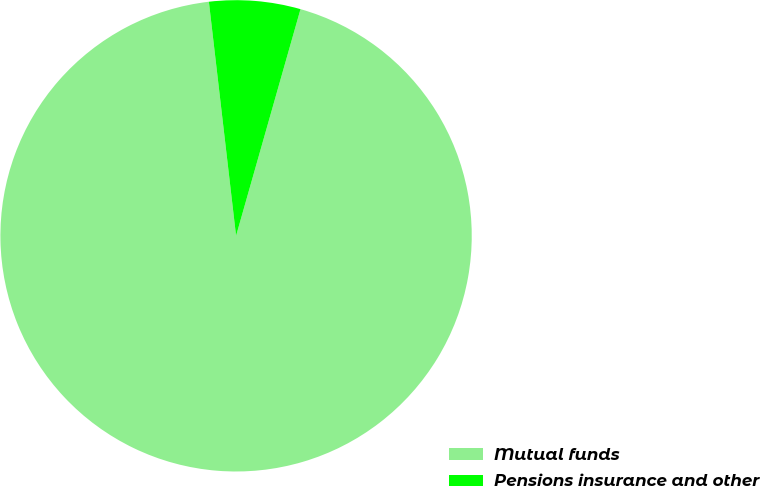Convert chart. <chart><loc_0><loc_0><loc_500><loc_500><pie_chart><fcel>Mutual funds<fcel>Pensions insurance and other<nl><fcel>93.75%<fcel>6.25%<nl></chart> 